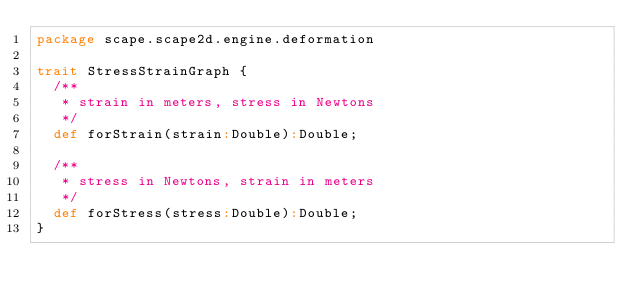Convert code to text. <code><loc_0><loc_0><loc_500><loc_500><_Scala_>package scape.scape2d.engine.deformation

trait StressStrainGraph {
  /**
   * strain in meters, stress in Newtons
   */
  def forStrain(strain:Double):Double;
  
  /**
   * stress in Newtons, strain in meters
   */
  def forStress(stress:Double):Double;
}</code> 